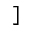Convert formula to latex. <formula><loc_0><loc_0><loc_500><loc_500>]</formula> 